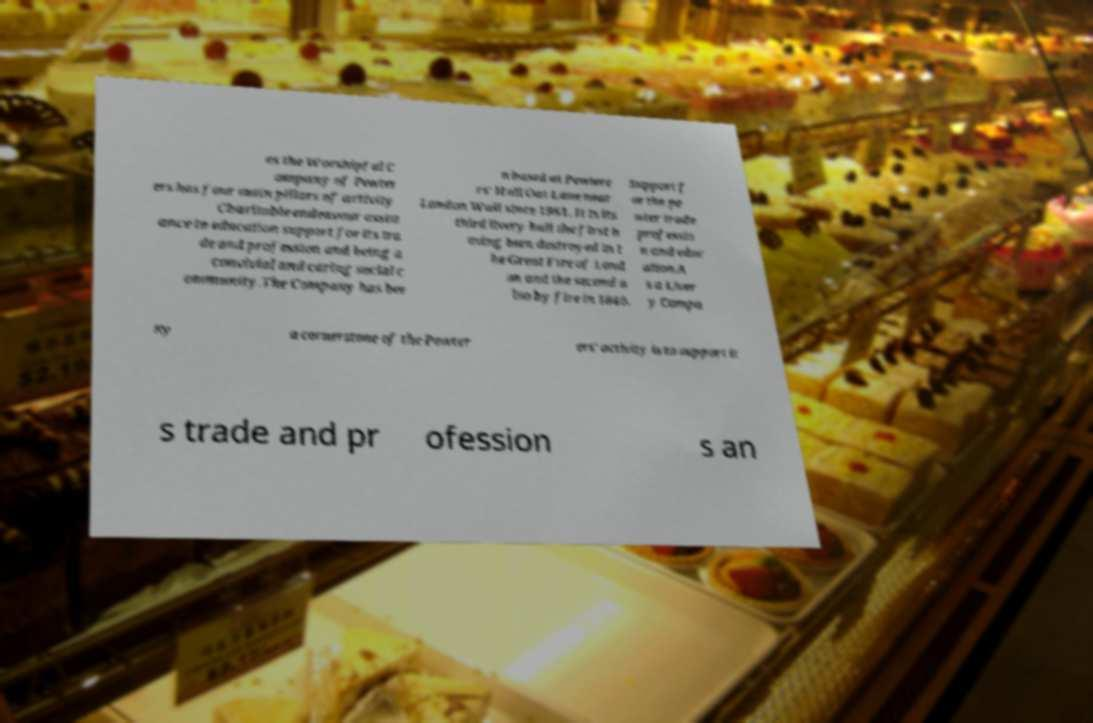Could you assist in decoding the text presented in this image and type it out clearly? es the Worshipful C ompany of Pewter ers has four main pillars of activity Charitable endeavour assist ance to education support for its tra de and profession and being a convivial and caring social c ommunity.The Company has bee n based at Pewtere rs' Hall Oat Lane near London Wall since 1961. It is its third livery hall the first h aving been destroyed in t he Great Fire of Lond on and the second a lso by fire in 1840. Support f or the pe wter trade professio n and educ ation.A s a Liver y Compa ny a cornerstone of the Pewter ers' activity is to support it s trade and pr ofession s an 